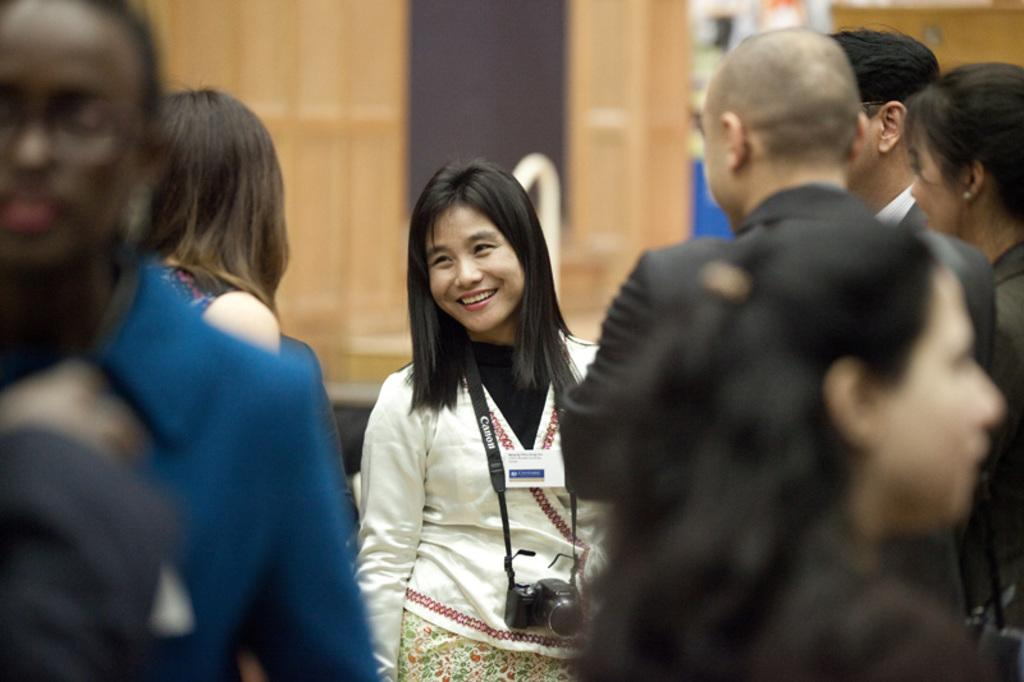How many people are in the image? There are people in the image, but the exact number is not specified. Can you describe the woman in the image? There is a woman standing and smiling in the image. What is the woman holding in the image? The woman is carrying a camera in the image. What can be said about the background of the image? The background of the image is not clear. How many dogs are visible in the image? There are no dogs present in the image. Is there a gun visible in the woman's hand in the image? No, there is no gun visible in the image; the woman is carrying a camera. 